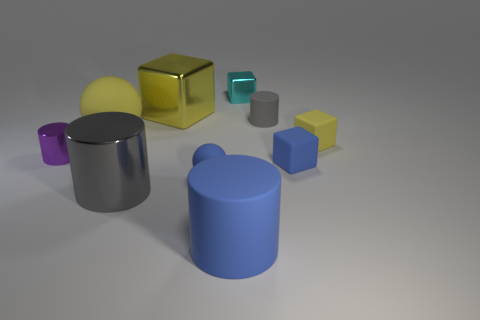Subtract 1 cubes. How many cubes are left? 3 Subtract all blue cylinders. Subtract all green blocks. How many cylinders are left? 3 Subtract all cylinders. How many objects are left? 6 Subtract all green shiny objects. Subtract all tiny rubber blocks. How many objects are left? 8 Add 9 big yellow blocks. How many big yellow blocks are left? 10 Add 6 tiny blue spheres. How many tiny blue spheres exist? 7 Subtract 0 brown cubes. How many objects are left? 10 